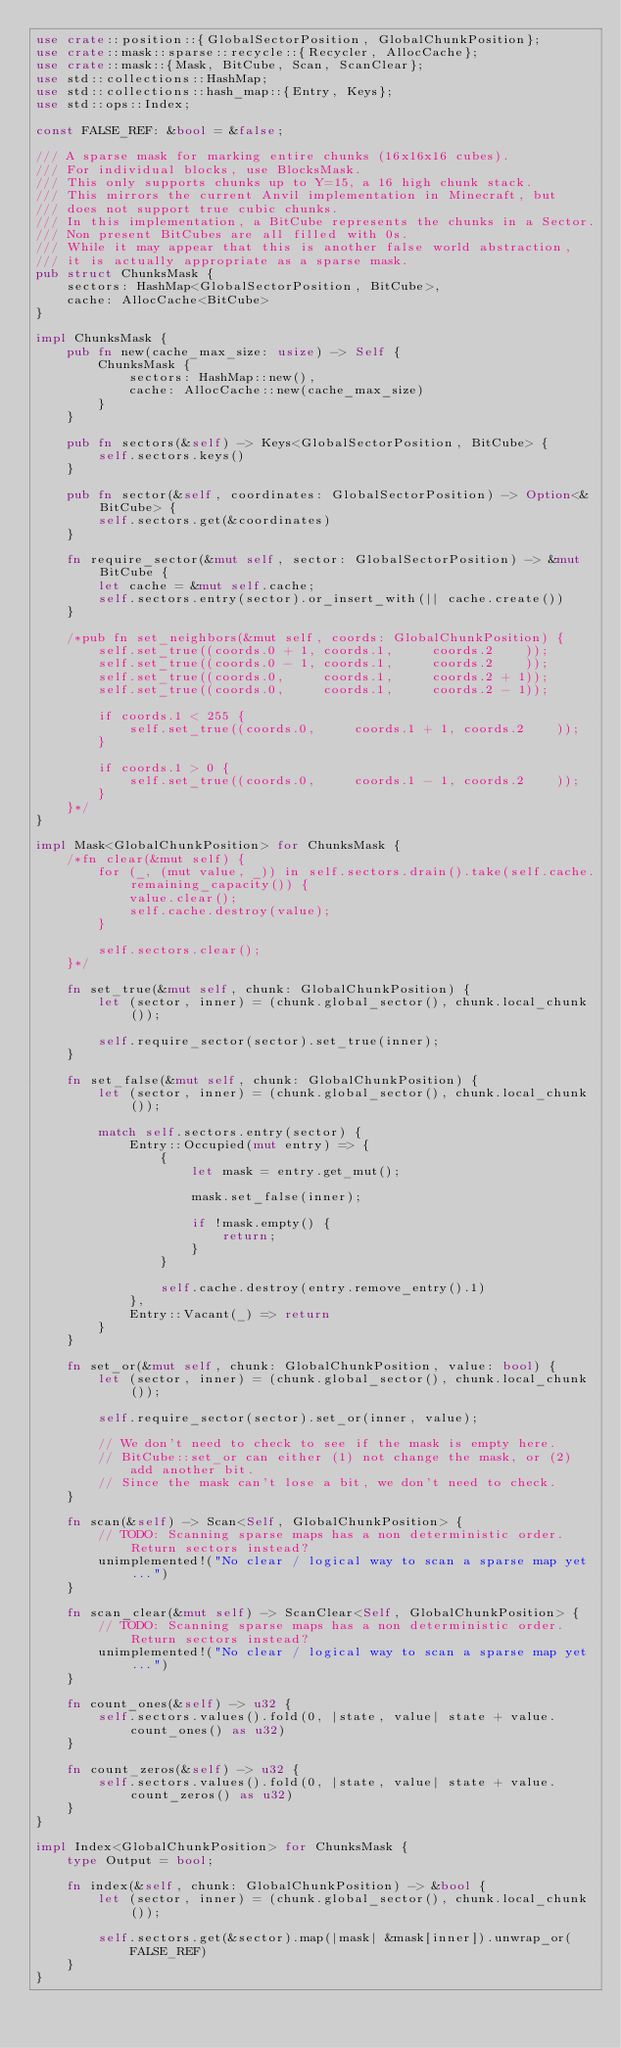<code> <loc_0><loc_0><loc_500><loc_500><_Rust_>use crate::position::{GlobalSectorPosition, GlobalChunkPosition};
use crate::mask::sparse::recycle::{Recycler, AllocCache};
use crate::mask::{Mask, BitCube, Scan, ScanClear};
use std::collections::HashMap;
use std::collections::hash_map::{Entry, Keys};
use std::ops::Index;

const FALSE_REF: &bool = &false;

/// A sparse mask for marking entire chunks (16x16x16 cubes).
/// For individual blocks, use BlocksMask.
/// This only supports chunks up to Y=15, a 16 high chunk stack.
/// This mirrors the current Anvil implementation in Minecraft, but
/// does not support true cubic chunks.
/// In this implementation, a BitCube represents the chunks in a Sector.
/// Non present BitCubes are all filled with 0s.
/// While it may appear that this is another false world abstraction,
/// it is actually appropriate as a sparse mask.
pub struct ChunksMask {
	sectors: HashMap<GlobalSectorPosition, BitCube>,
	cache: AllocCache<BitCube>
}

impl ChunksMask {
	pub fn new(cache_max_size: usize) -> Self {
		ChunksMask {
			sectors: HashMap::new(),
			cache: AllocCache::new(cache_max_size)
		}
	}

	pub fn sectors(&self) -> Keys<GlobalSectorPosition, BitCube> {
		self.sectors.keys()
	}

	pub fn sector(&self, coordinates: GlobalSectorPosition) -> Option<&BitCube> {
		self.sectors.get(&coordinates)
	}

	fn require_sector(&mut self, sector: GlobalSectorPosition) -> &mut BitCube {
		let cache = &mut self.cache;
		self.sectors.entry(sector).or_insert_with(|| cache.create())
	}

	/*pub fn set_neighbors(&mut self, coords: GlobalChunkPosition) {
		self.set_true((coords.0 + 1, coords.1,     coords.2    ));
		self.set_true((coords.0 - 1, coords.1,     coords.2    ));
		self.set_true((coords.0,     coords.1,     coords.2 + 1));
		self.set_true((coords.0,     coords.1,     coords.2 - 1));

		if coords.1 < 255 {
			self.set_true((coords.0,     coords.1 + 1, coords.2    ));
		}

		if coords.1 > 0 {
			self.set_true((coords.0,     coords.1 - 1, coords.2    ));
		}
	}*/
}

impl Mask<GlobalChunkPosition> for ChunksMask {
	/*fn clear(&mut self) {
		for (_, (mut value, _)) in self.sectors.drain().take(self.cache.remaining_capacity()) {
			value.clear();
			self.cache.destroy(value);
		}

		self.sectors.clear();
	}*/

	fn set_true(&mut self, chunk: GlobalChunkPosition) {
		let (sector, inner) = (chunk.global_sector(), chunk.local_chunk());

		self.require_sector(sector).set_true(inner);
	}

	fn set_false(&mut self, chunk: GlobalChunkPosition) {
		let (sector, inner) = (chunk.global_sector(), chunk.local_chunk());

		match self.sectors.entry(sector) {
			Entry::Occupied(mut entry) => {
				{
					let mask = entry.get_mut();

					mask.set_false(inner);

					if !mask.empty() {
						return;
					}
				}

				self.cache.destroy(entry.remove_entry().1)
			},
			Entry::Vacant(_) => return
		}
	}

	fn set_or(&mut self, chunk: GlobalChunkPosition, value: bool) {
		let (sector, inner) = (chunk.global_sector(), chunk.local_chunk());

		self.require_sector(sector).set_or(inner, value);

		// We don't need to check to see if the mask is empty here.
		// BitCube::set_or can either (1) not change the mask, or (2) add another bit.
		// Since the mask can't lose a bit, we don't need to check.
	}

	fn scan(&self) -> Scan<Self, GlobalChunkPosition> {
		// TODO: Scanning sparse maps has a non deterministic order. Return sectors instead?
		unimplemented!("No clear / logical way to scan a sparse map yet...")
	}

	fn scan_clear(&mut self) -> ScanClear<Self, GlobalChunkPosition> {
		// TODO: Scanning sparse maps has a non deterministic order. Return sectors instead?
		unimplemented!("No clear / logical way to scan a sparse map yet...")
	}

	fn count_ones(&self) -> u32 {
		self.sectors.values().fold(0, |state, value| state + value.count_ones() as u32)
	}

	fn count_zeros(&self) -> u32 {
		self.sectors.values().fold(0, |state, value| state + value.count_zeros() as u32)
	}
}

impl Index<GlobalChunkPosition> for ChunksMask {
	type Output = bool;

	fn index(&self, chunk: GlobalChunkPosition) -> &bool {
		let (sector, inner) = (chunk.global_sector(), chunk.local_chunk());

		self.sectors.get(&sector).map(|mask| &mask[inner]).unwrap_or(FALSE_REF)
	}
}</code> 